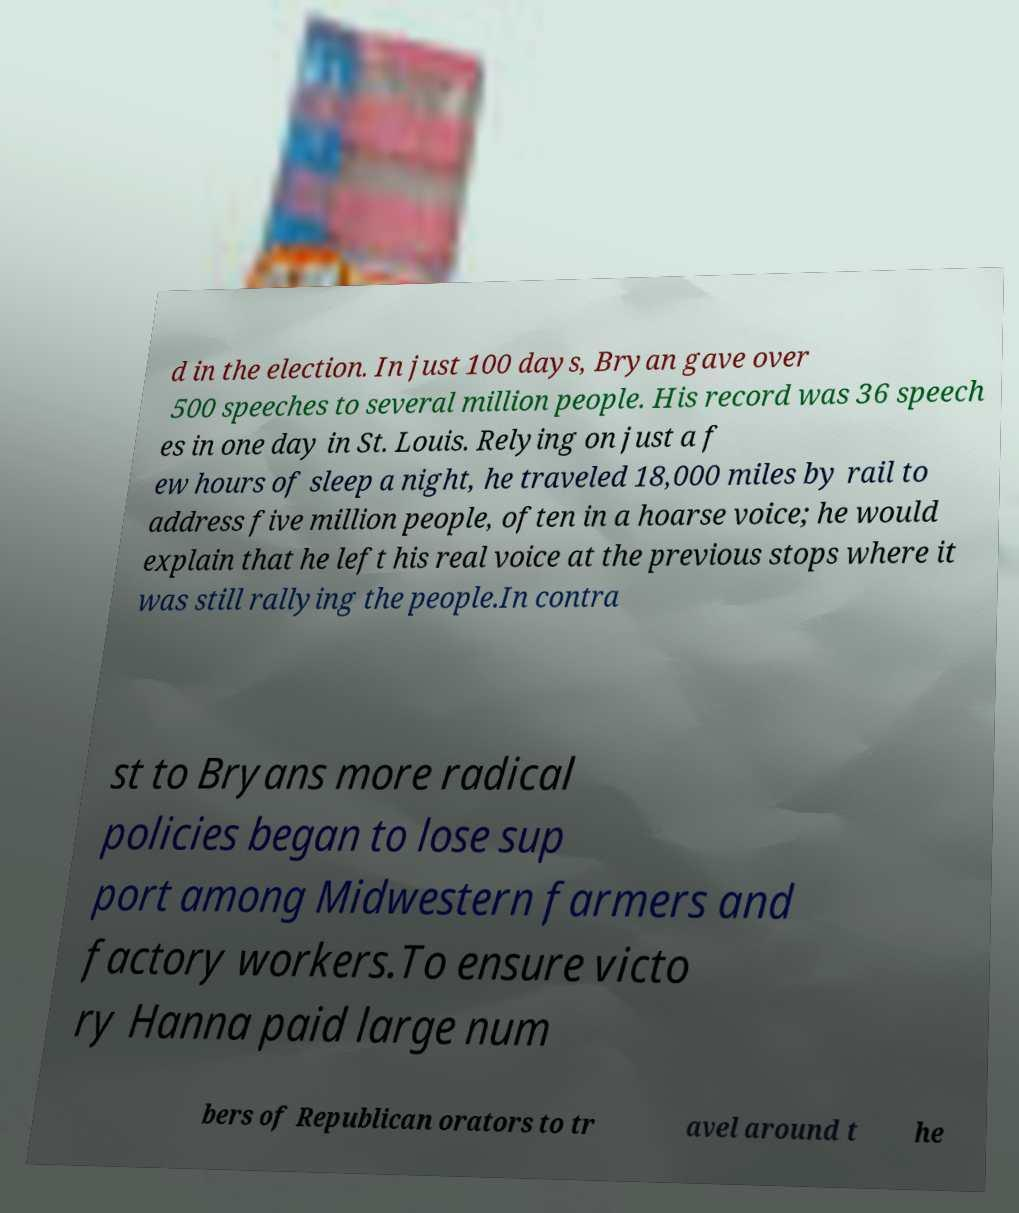For documentation purposes, I need the text within this image transcribed. Could you provide that? d in the election. In just 100 days, Bryan gave over 500 speeches to several million people. His record was 36 speech es in one day in St. Louis. Relying on just a f ew hours of sleep a night, he traveled 18,000 miles by rail to address five million people, often in a hoarse voice; he would explain that he left his real voice at the previous stops where it was still rallying the people.In contra st to Bryans more radical policies began to lose sup port among Midwestern farmers and factory workers.To ensure victo ry Hanna paid large num bers of Republican orators to tr avel around t he 